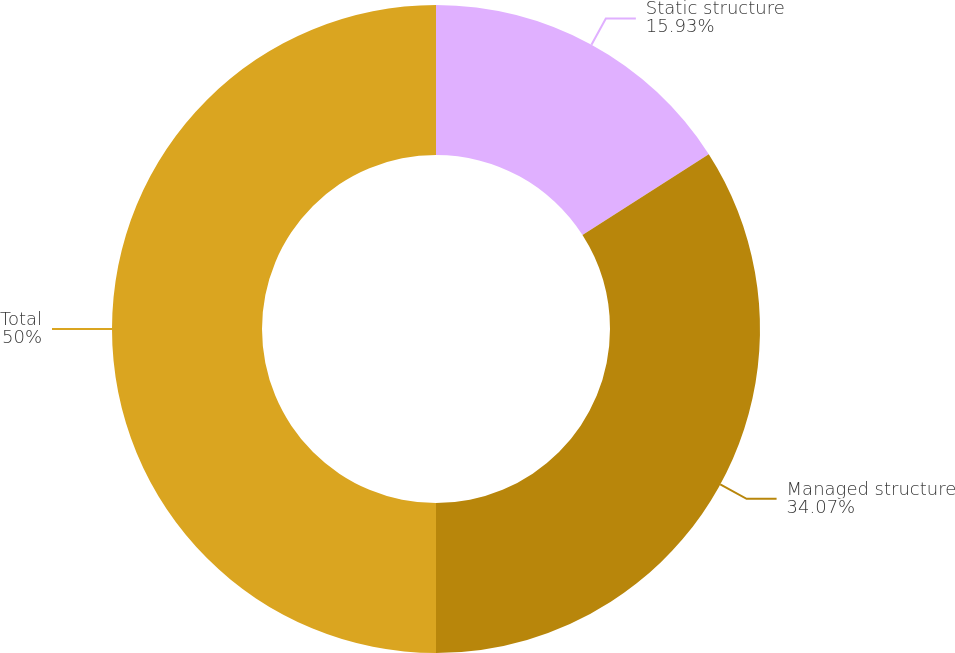<chart> <loc_0><loc_0><loc_500><loc_500><pie_chart><fcel>Static structure<fcel>Managed structure<fcel>Total<nl><fcel>15.93%<fcel>34.07%<fcel>50.0%<nl></chart> 